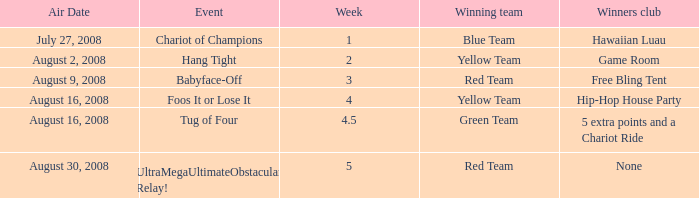Can you give me this table as a dict? {'header': ['Air Date', 'Event', 'Week', 'Winning team', 'Winners club'], 'rows': [['July 27, 2008', 'Chariot of Champions', '1', 'Blue Team', 'Hawaiian Luau'], ['August 2, 2008', 'Hang Tight', '2', 'Yellow Team', 'Game Room'], ['August 9, 2008', 'Babyface-Off', '3', 'Red Team', 'Free Bling Tent'], ['August 16, 2008', 'Foos It or Lose It', '4', 'Yellow Team', 'Hip-Hop House Party'], ['August 16, 2008', 'Tug of Four', '4.5', 'Green Team', '5 extra points and a Chariot Ride'], ['August 30, 2008', 'UltraMegaUltimateObstacular Relay!', '5', 'Red Team', 'None']]} Which Week has an Air Date of august 30, 2008? 5.0. 